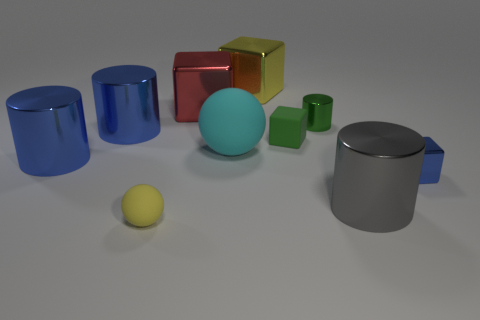What size is the cyan matte sphere?
Make the answer very short. Large. There is a large red thing that is made of the same material as the tiny green cylinder; what is its shape?
Ensure brevity in your answer.  Cube. Are there fewer large gray cylinders in front of the red metal cube than large blue metallic cylinders?
Your answer should be compact. Yes. The matte ball that is right of the red block is what color?
Your response must be concise. Cyan. There is a large cube that is the same color as the tiny sphere; what is it made of?
Provide a short and direct response. Metal. Is there a large yellow metallic object that has the same shape as the large red shiny object?
Offer a very short reply. Yes. How many large yellow objects have the same shape as the tiny yellow thing?
Make the answer very short. 0. Does the large ball have the same color as the small sphere?
Your answer should be compact. No. Is the number of purple rubber balls less than the number of tiny things?
Provide a succinct answer. Yes. What is the material of the yellow thing on the left side of the red metal cube?
Your response must be concise. Rubber. 